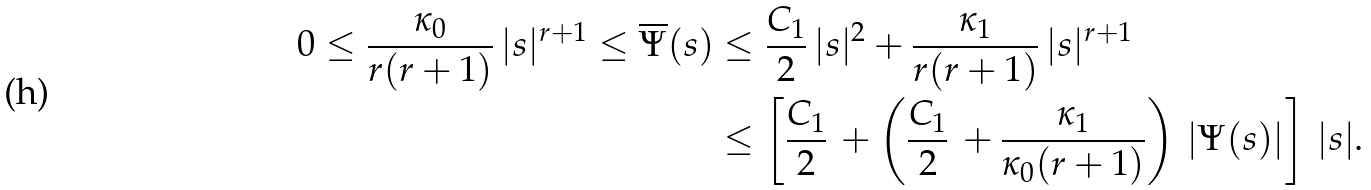Convert formula to latex. <formula><loc_0><loc_0><loc_500><loc_500>0 \leq \frac { \kappa _ { 0 } } { r ( r + 1 ) } \, | s | ^ { r + 1 } \leq \overline { \Psi } ( s ) & \leq \frac { C _ { 1 } } { 2 } \, | s | ^ { 2 } + \frac { \kappa _ { 1 } } { r ( r + 1 ) } \, | s | ^ { r + 1 } \\ & \leq \left [ \frac { C _ { 1 } } { 2 } \, + \left ( \frac { C _ { 1 } } { 2 } \, + \frac { \kappa _ { 1 } } { \kappa _ { 0 } ( r + 1 ) } \right ) \, | \Psi ( s ) | \right ] \, | s | .</formula> 